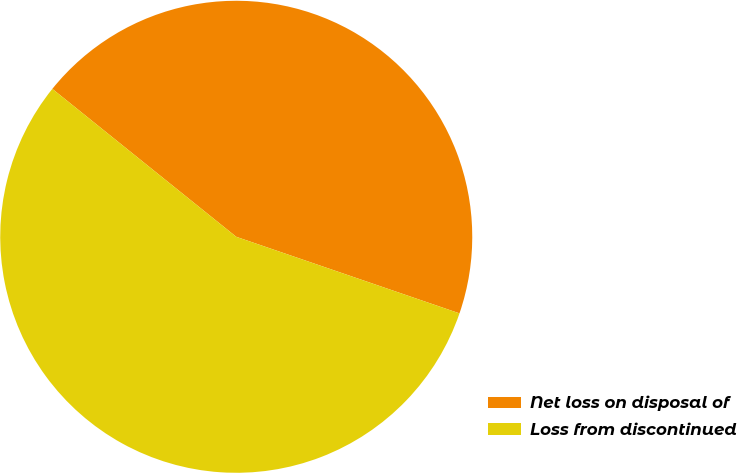<chart> <loc_0><loc_0><loc_500><loc_500><pie_chart><fcel>Net loss on disposal of<fcel>Loss from discontinued<nl><fcel>44.48%<fcel>55.52%<nl></chart> 